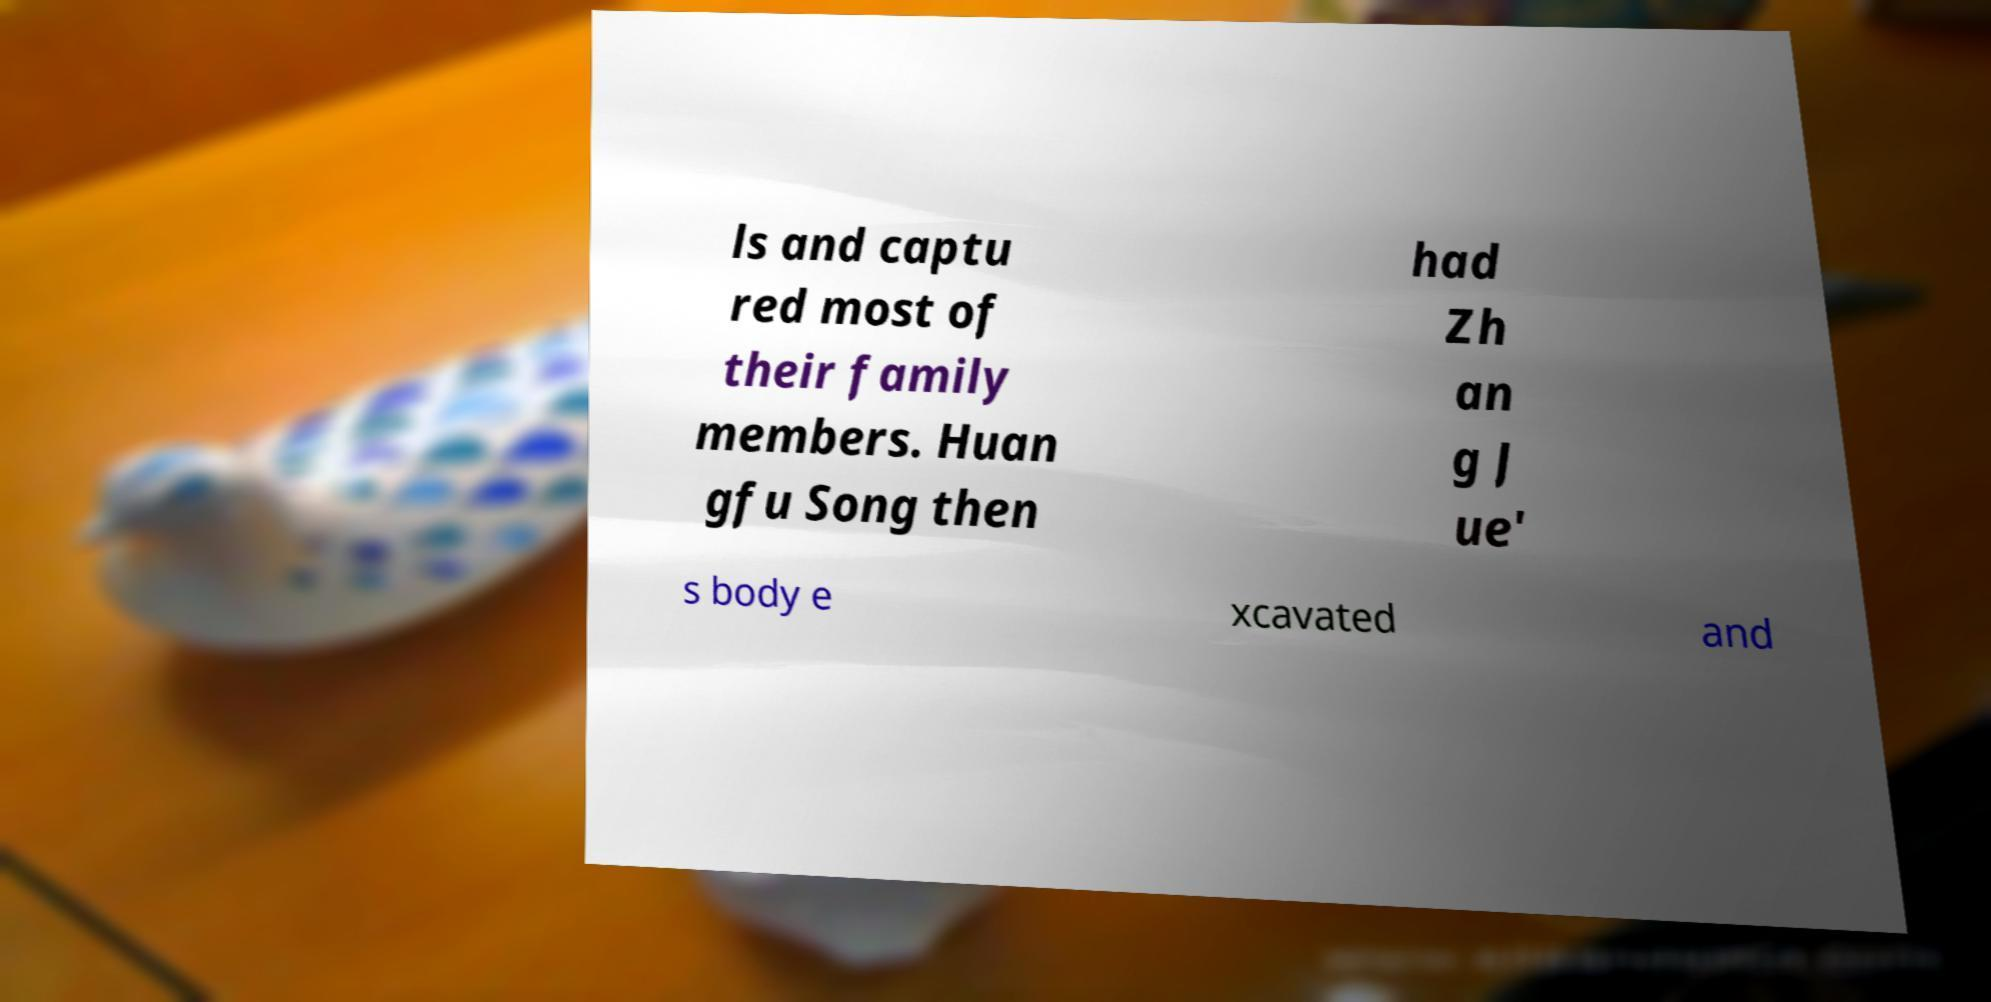Can you accurately transcribe the text from the provided image for me? ls and captu red most of their family members. Huan gfu Song then had Zh an g J ue' s body e xcavated and 